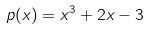<formula> <loc_0><loc_0><loc_500><loc_500>p ( x ) = x ^ { 3 } + 2 x - 3</formula> 